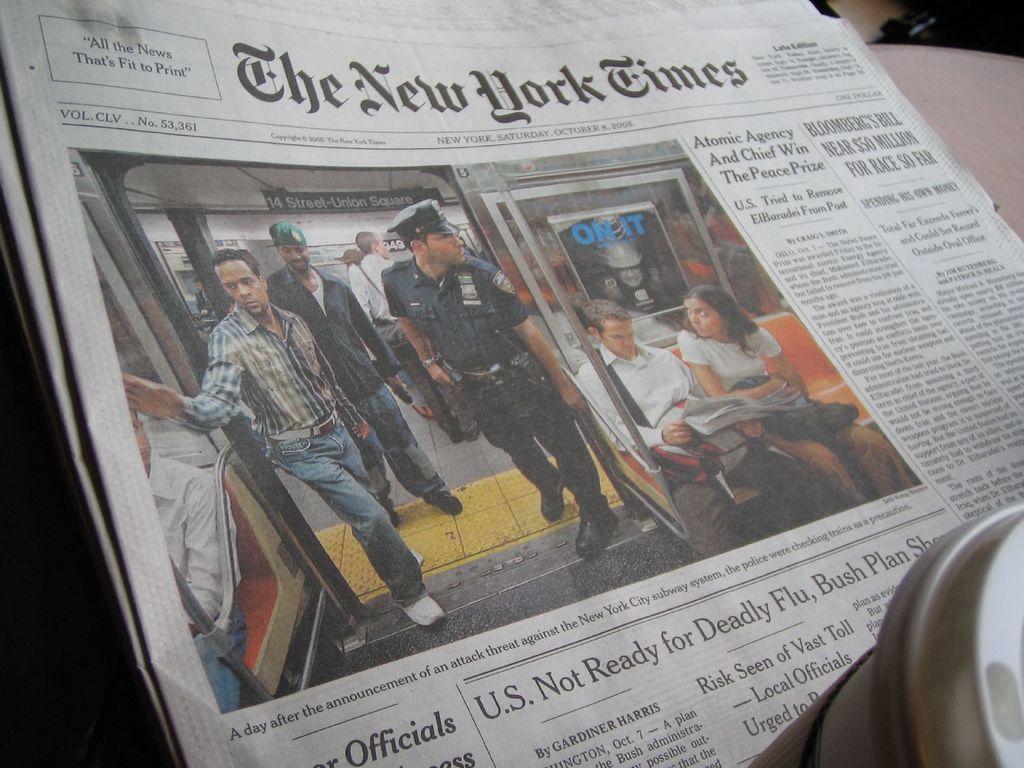Describe this image in one or two sentences. We can see new paper on the surface,on this paper we can see people. 